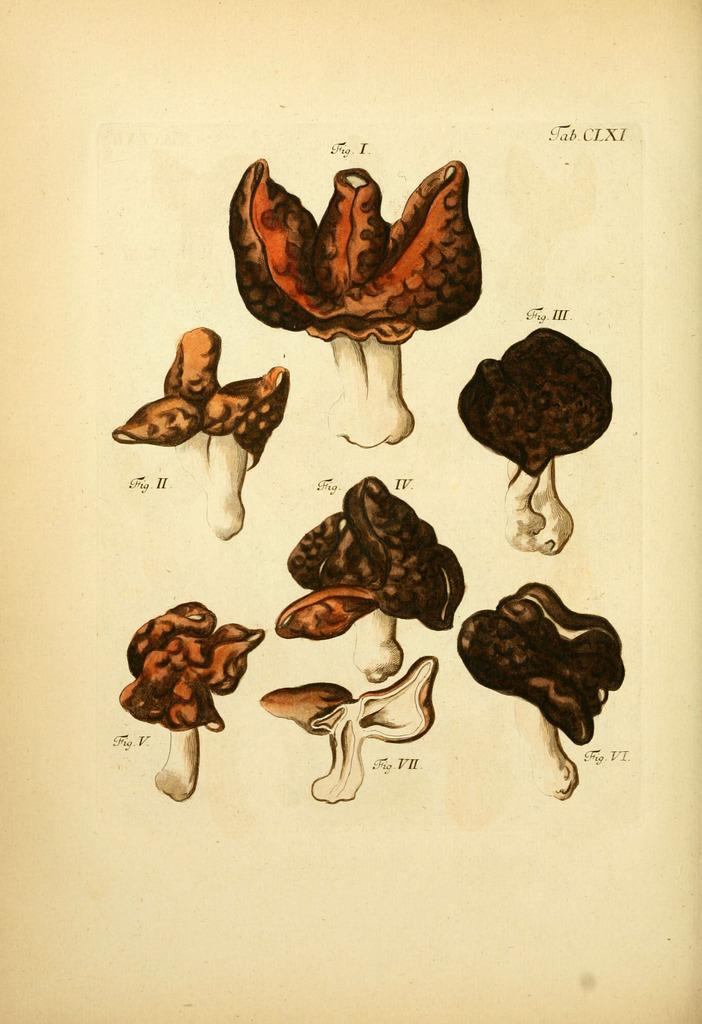What is the main subject of the pictures in the image? The main subject of the pictures in the image is mushrooms. Can you describe the variety of mushrooms depicted in the pictures? The mushrooms depicted in the pictures are of different types. What is the condition of the pin in the image? There is no pin present in the image. What type of boundary is depicted in the image? There is no boundary depicted in the image; it only contains pictures of mushrooms. 